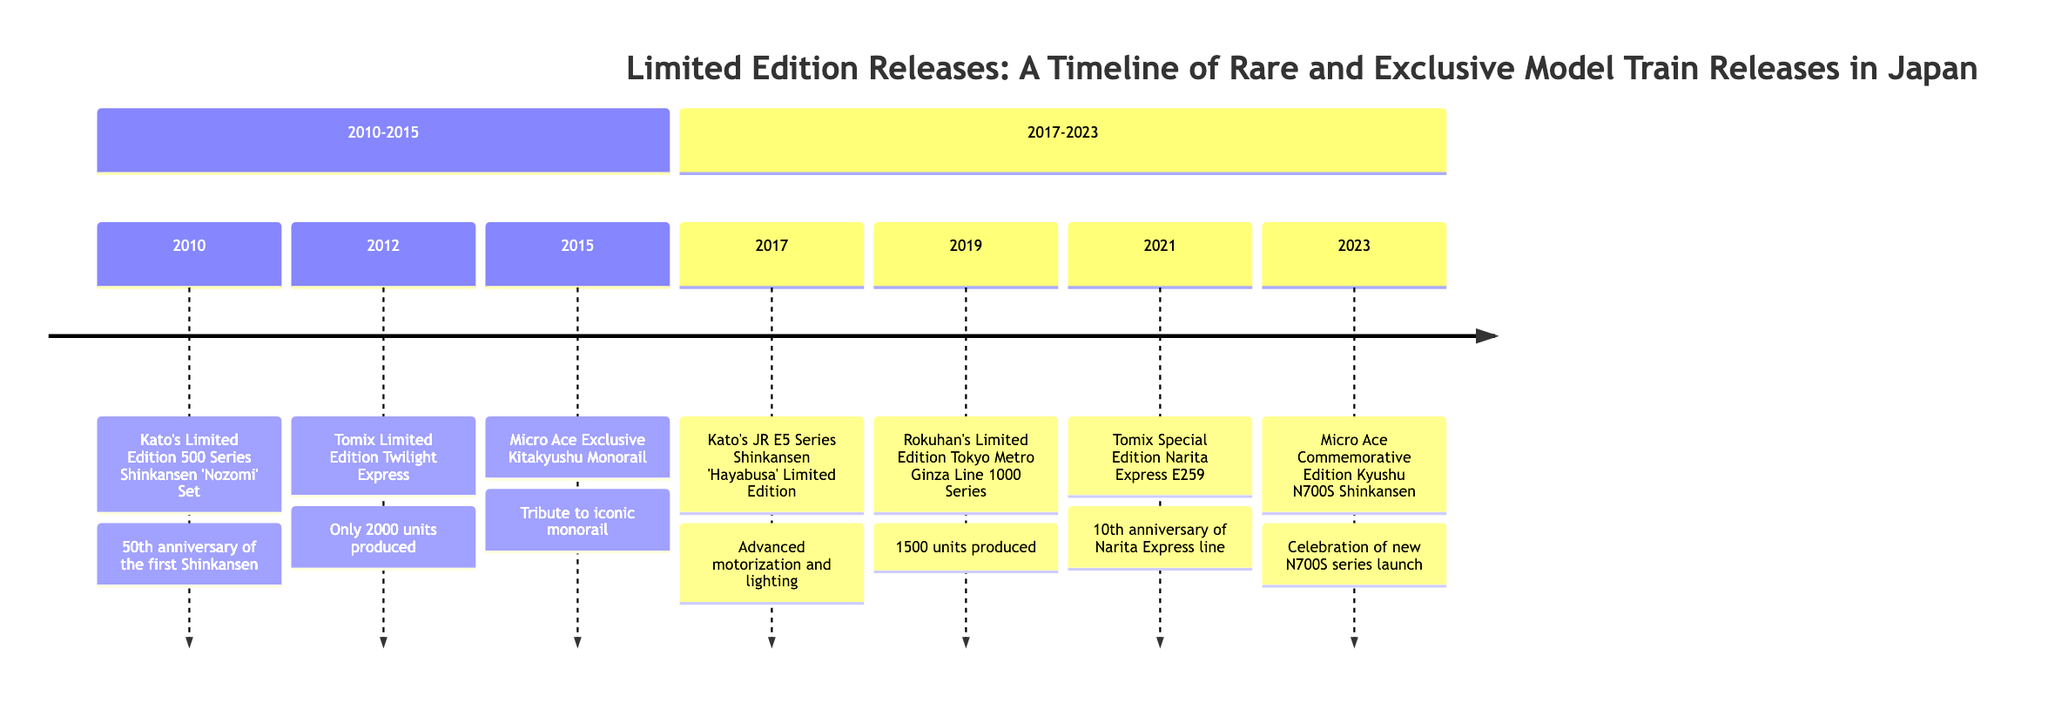What year was the limited edition release of Kato's 500 Series Shinkansen 'Nozomi'? The timeline indicates that Kato's 500 Series Shinkansen 'Nozomi' was first released in 2010.
Answer: 2010 How many units were produced for the Tomix Limited Edition Twilight Express? The timeline specifies that only 2000 units were produced for the Tomix Limited Edition Twilight Express.
Answer: 2000 Which model commemorated the 10th anniversary of the Narita Express line? According to the timeline, the Tomix Special Edition Narita Express E259 was released to mark the 10th anniversary of the Narita Express line.
Answer: Tomix Special Edition Narita Express E259 What is the release year of the Micro Ace Commemorative Edition Kyushu N700S Shinkansen? The timeline shows that the Micro Ace Commemorative Edition Kyushu N700S Shinkansen was released in 2023.
Answer: 2023 Which manufacturer released the JR E5 Series Shinkansen 'Hayabusa' Limited Edition? The timeline lists Kato as the manufacturer for the JR E5 Series Shinkansen 'Hayabusa' Limited Edition.
Answer: Kato What notable feature was highlighted in Kato's JR E5 Series Shinkansen 'Hayabusa'? The timeline details the advanced motorization and lighting features as notable in Kato's JR E5 Series Shinkansen 'Hayabusa'.
Answer: Advanced motorization and lighting How many limited edition units were produced for the Rokuhan's Tokyo Metro Ginza Line 1000 Series? The timeline indicates that Rokuhan's Tokyo Metro Ginza Line 1000 Series was released in a limited run of 1500 units.
Answer: 1500 What unique aspect characterized the Micro Ace Exclusive Kitakyushu Monorail? The timeline indicates that the Micro Ace Exclusive Kitakyushu Monorail featured unique livery details and was a tribute to the iconic monorail.
Answer: Unique livery details Which model was released in celebration of the new N700S series in Kyushu? The timeline notes that the Micro Ace Commemorative Edition Kyushu N700S Shinkansen was released to celebrate the new N700S series in Kyushu.
Answer: Micro Ace Commemorative Edition Kyushu N700S Shinkansen 